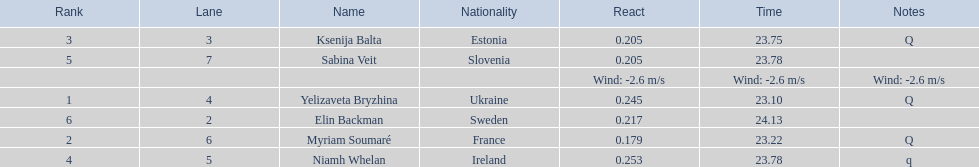Which athlete is from sweden? Elin Backman. What was their time to finish the race? 24.13. 